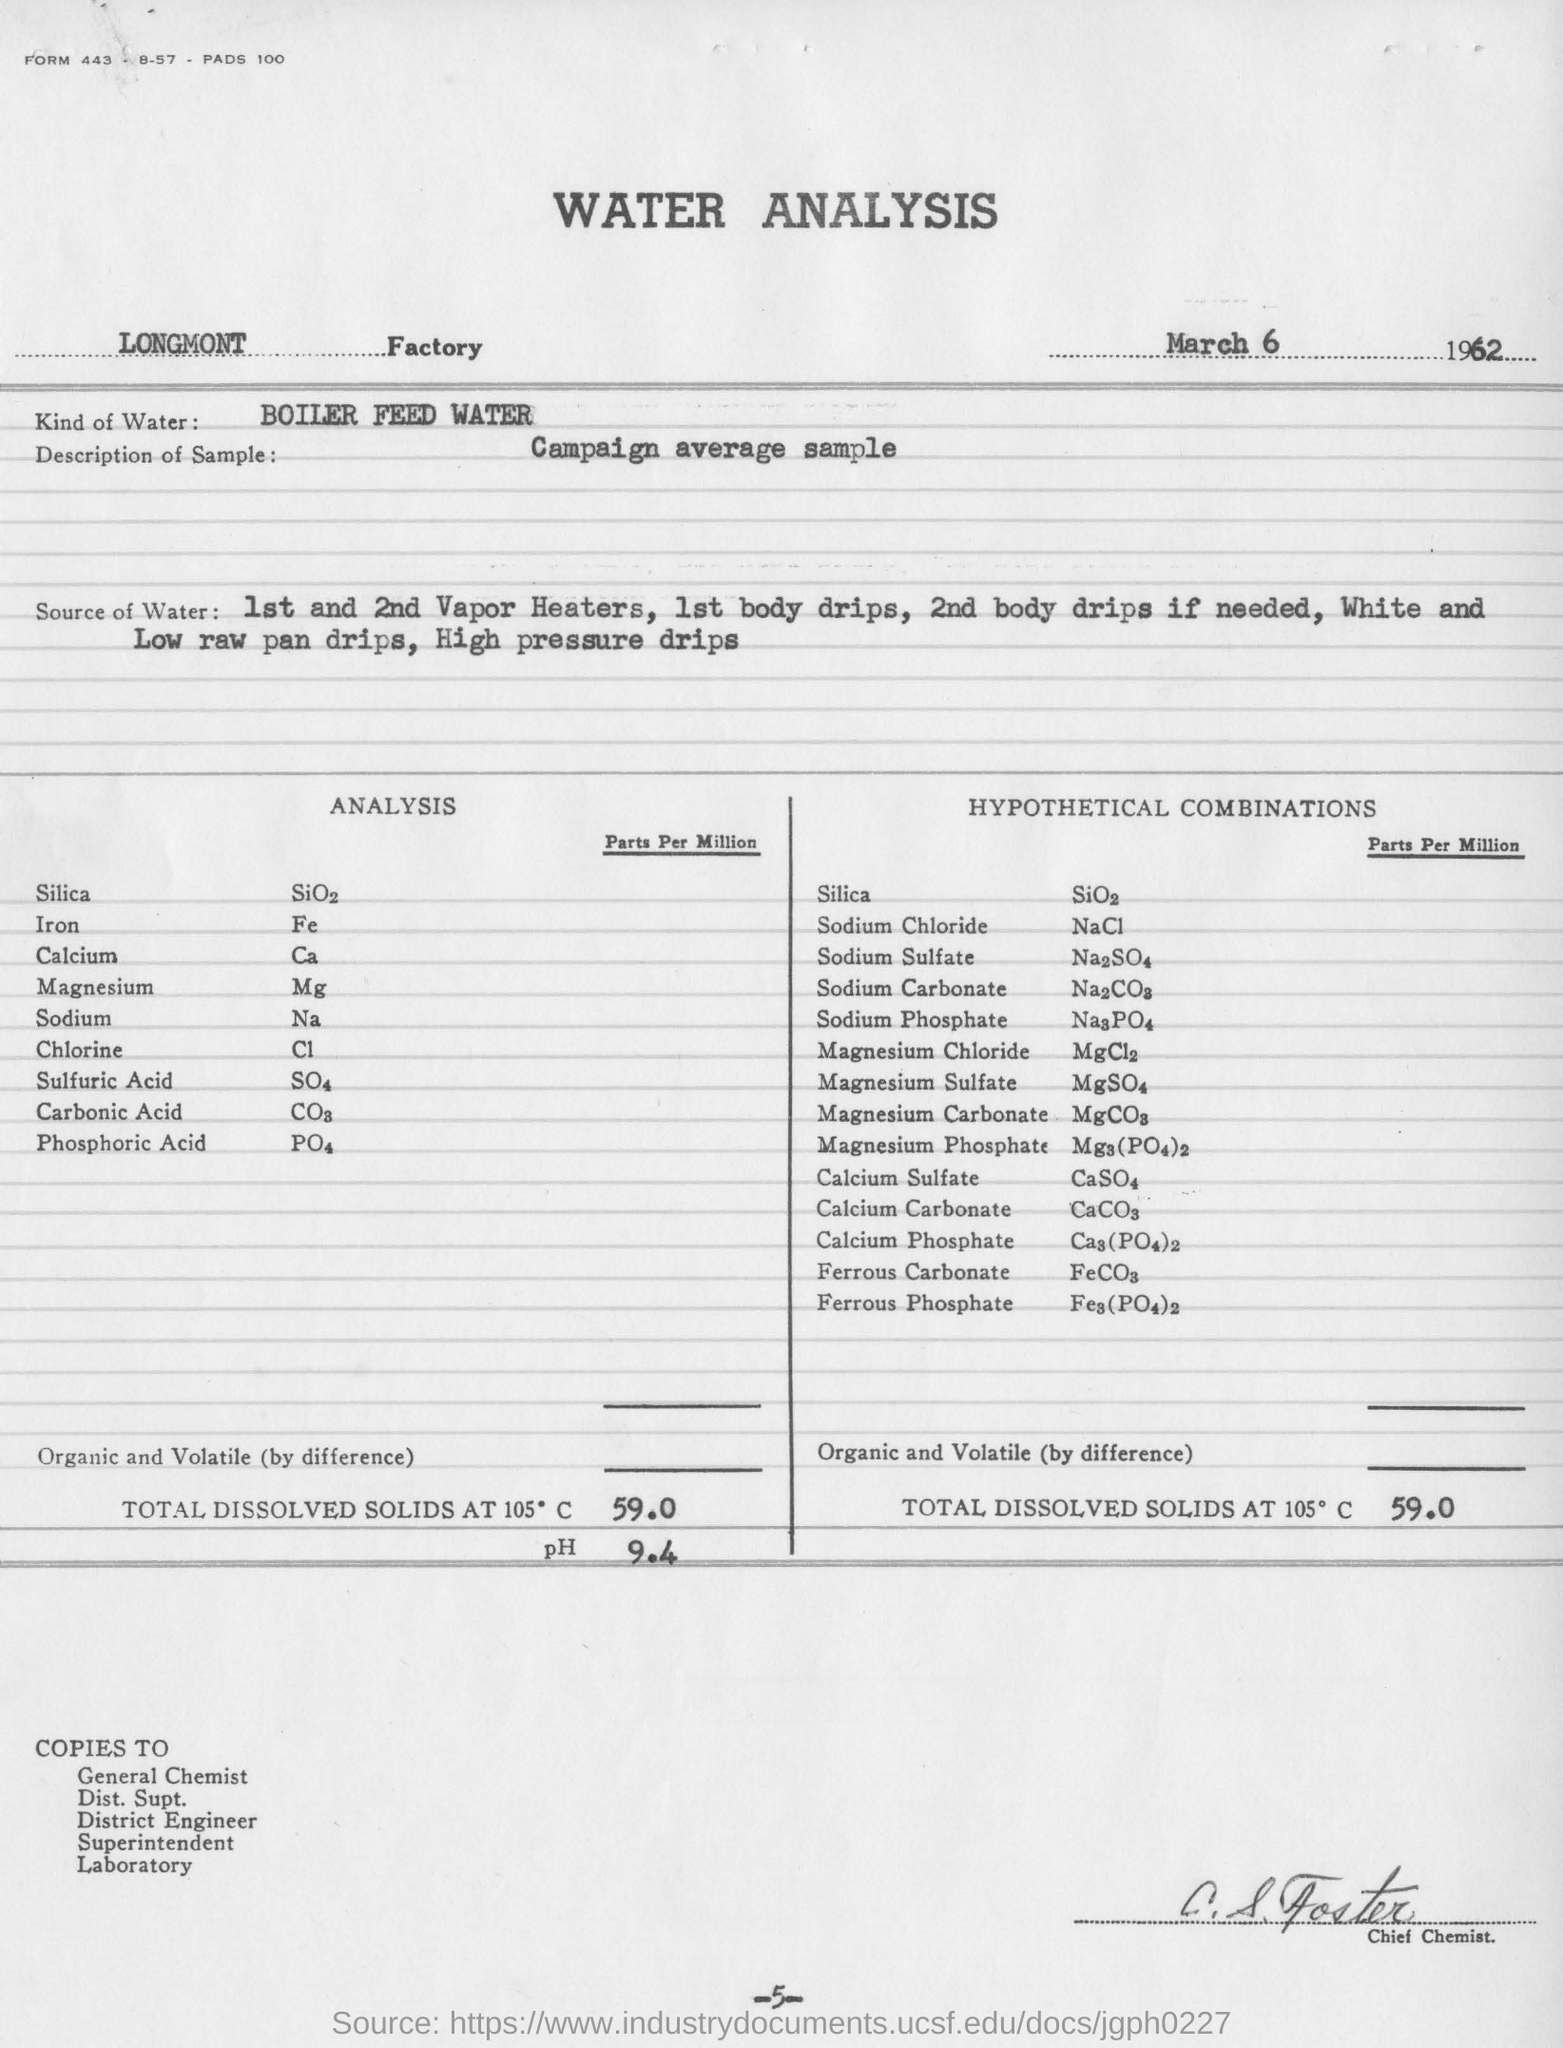In which Factory is the analysis conducted?
Your answer should be very brief. Longmont factory. What kind of water is used for the analysis?
Make the answer very short. Boiler feed water. What is the page no mentioned in this document?
Give a very brief answer. 5. What is the designation of the person undersigned?
Offer a terse response. Chief chemist. What is the description of sample taken for the water analysis?
Your answer should be very brief. Campaign average sample. 